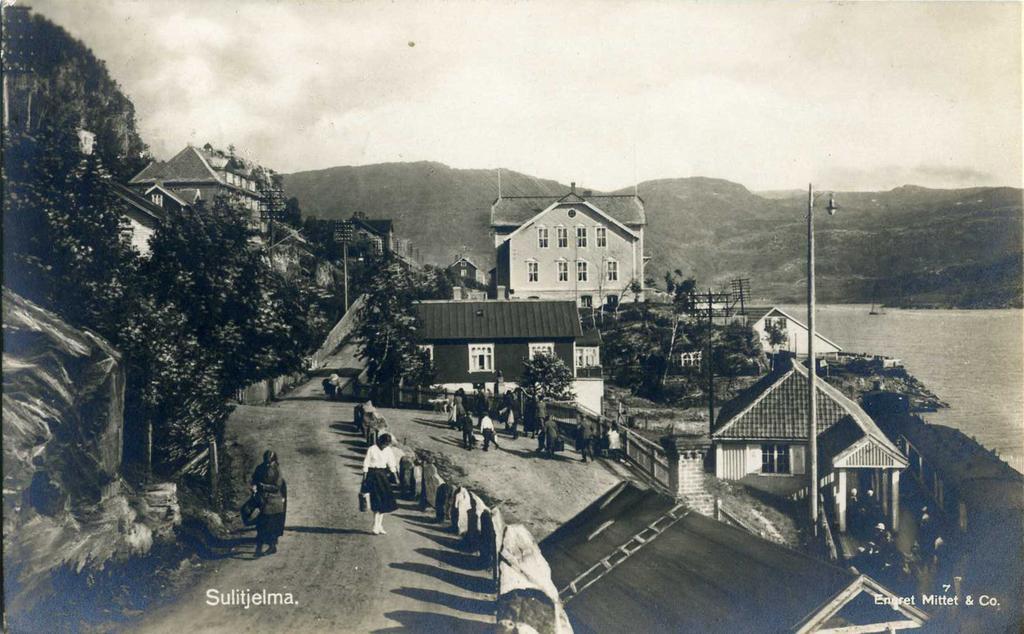Please provide a concise description of this image. In this image there are group of people and some houses, trees, poles, wires, and some objects. In the center and in the background there are mountains, on the right side of the image there is river. At the top there is sky. 